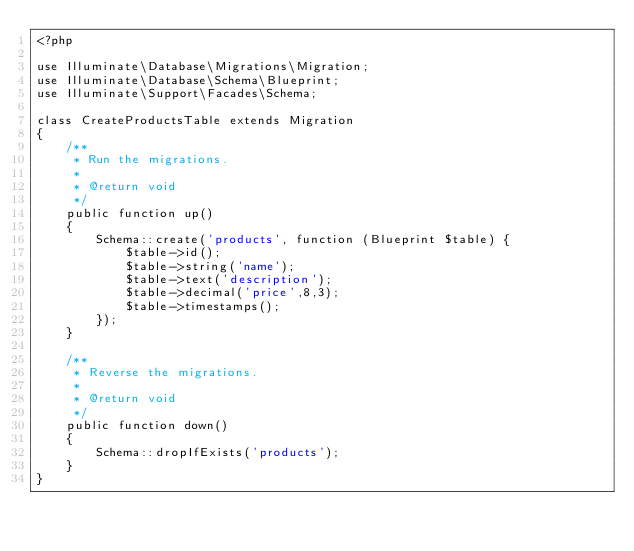<code> <loc_0><loc_0><loc_500><loc_500><_PHP_><?php

use Illuminate\Database\Migrations\Migration;
use Illuminate\Database\Schema\Blueprint;
use Illuminate\Support\Facades\Schema;

class CreateProductsTable extends Migration
{
    /**
     * Run the migrations.
     *
     * @return void
     */
    public function up()
    {
        Schema::create('products', function (Blueprint $table) {
            $table->id();
            $table->string('name');
            $table->text('description');
            $table->decimal('price',8,3);
            $table->timestamps();
        });
    }

    /**
     * Reverse the migrations.
     *
     * @return void
     */
    public function down()
    {
        Schema::dropIfExists('products');
    }
}
</code> 